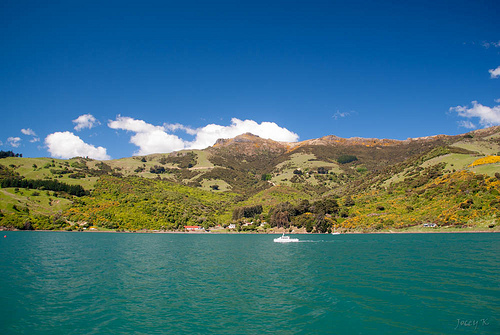<image>
Is the cloud above the mountain? Yes. The cloud is positioned above the mountain in the vertical space, higher up in the scene. 